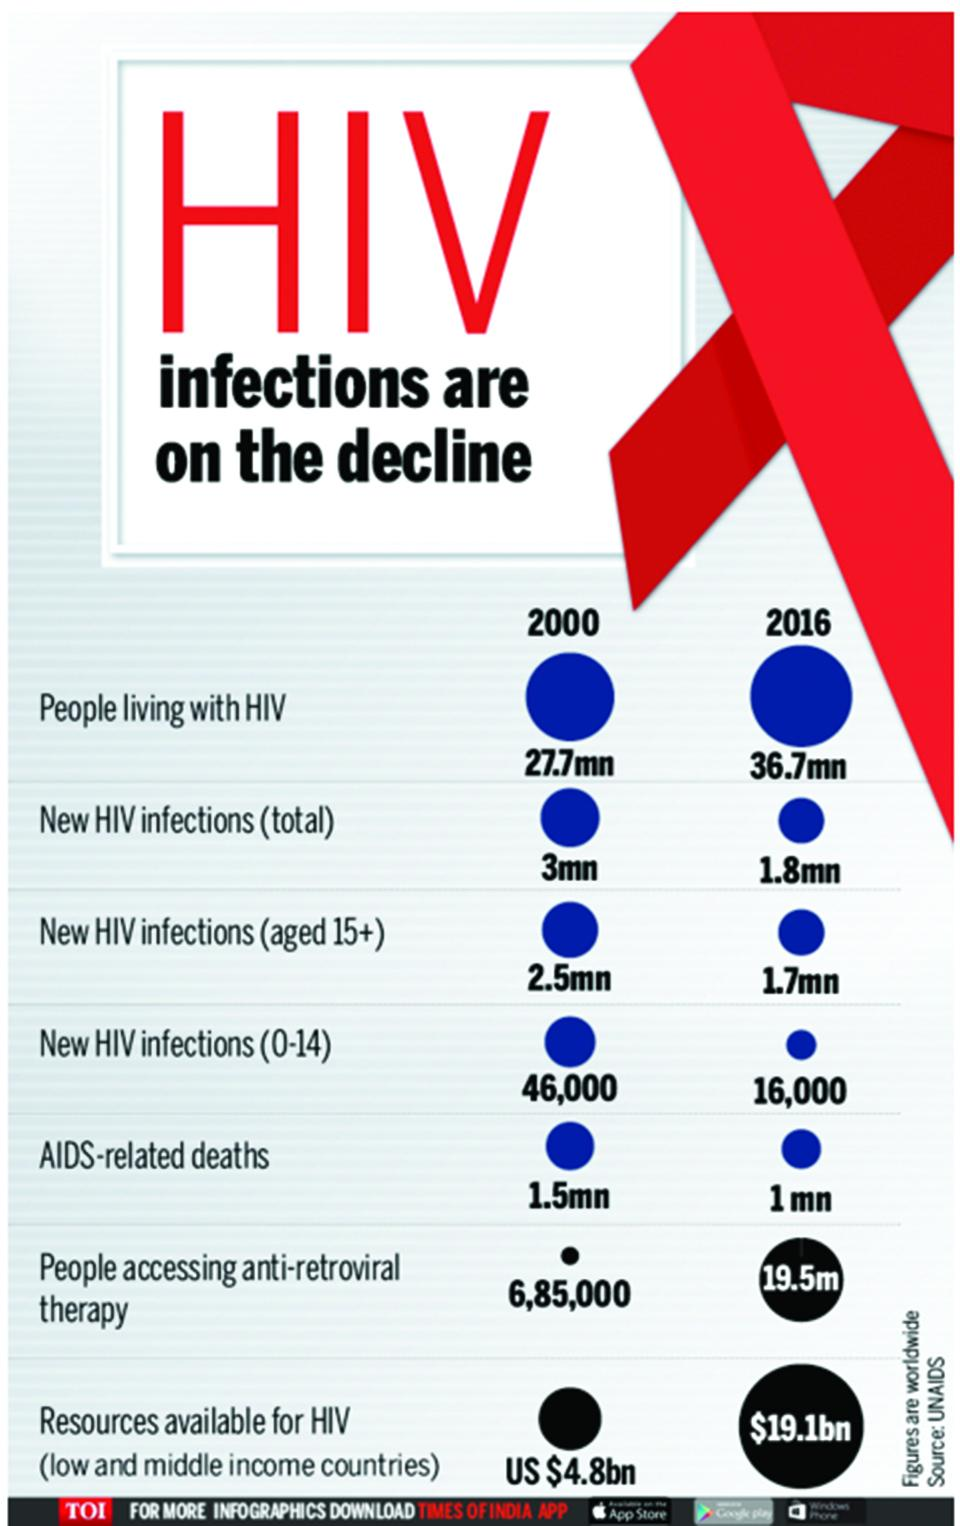List a handful of essential elements in this visual. In 2016, it is estimated that approximately 19.5 million people worldwide were living with HIV and receiving antiretroviral therapy. In 2016, globally, it was reported that 1.7 million cases of HIV infection in individuals aged 15 years and above were newly diagnosed. In 2000, an estimated 1.5 million people worldwide were killed as a result of AIDS. In 2016, there were approximately 16,000 newly infected HIV cases in the age group of 0-14 years globally. In 2000, it is estimated that approximately 3 million new cases of HIV were diagnosed worldwide. 